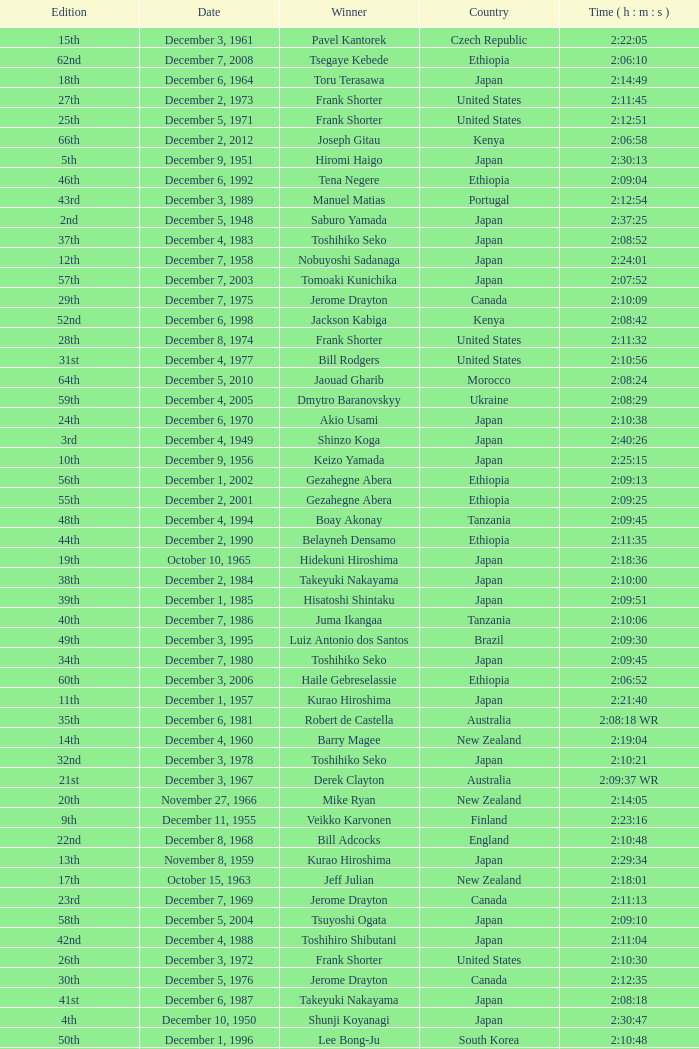On what date did Lee Bong-Ju win in 2:10:48? December 1, 1996. Can you parse all the data within this table? {'header': ['Edition', 'Date', 'Winner', 'Country', 'Time ( h : m : s )'], 'rows': [['15th', 'December 3, 1961', 'Pavel Kantorek', 'Czech Republic', '2:22:05'], ['62nd', 'December 7, 2008', 'Tsegaye Kebede', 'Ethiopia', '2:06:10'], ['18th', 'December 6, 1964', 'Toru Terasawa', 'Japan', '2:14:49'], ['27th', 'December 2, 1973', 'Frank Shorter', 'United States', '2:11:45'], ['25th', 'December 5, 1971', 'Frank Shorter', 'United States', '2:12:51'], ['66th', 'December 2, 2012', 'Joseph Gitau', 'Kenya', '2:06:58'], ['5th', 'December 9, 1951', 'Hiromi Haigo', 'Japan', '2:30:13'], ['46th', 'December 6, 1992', 'Tena Negere', 'Ethiopia', '2:09:04'], ['43rd', 'December 3, 1989', 'Manuel Matias', 'Portugal', '2:12:54'], ['2nd', 'December 5, 1948', 'Saburo Yamada', 'Japan', '2:37:25'], ['37th', 'December 4, 1983', 'Toshihiko Seko', 'Japan', '2:08:52'], ['12th', 'December 7, 1958', 'Nobuyoshi Sadanaga', 'Japan', '2:24:01'], ['57th', 'December 7, 2003', 'Tomoaki Kunichika', 'Japan', '2:07:52'], ['29th', 'December 7, 1975', 'Jerome Drayton', 'Canada', '2:10:09'], ['52nd', 'December 6, 1998', 'Jackson Kabiga', 'Kenya', '2:08:42'], ['28th', 'December 8, 1974', 'Frank Shorter', 'United States', '2:11:32'], ['31st', 'December 4, 1977', 'Bill Rodgers', 'United States', '2:10:56'], ['64th', 'December 5, 2010', 'Jaouad Gharib', 'Morocco', '2:08:24'], ['59th', 'December 4, 2005', 'Dmytro Baranovskyy', 'Ukraine', '2:08:29'], ['24th', 'December 6, 1970', 'Akio Usami', 'Japan', '2:10:38'], ['3rd', 'December 4, 1949', 'Shinzo Koga', 'Japan', '2:40:26'], ['10th', 'December 9, 1956', 'Keizo Yamada', 'Japan', '2:25:15'], ['56th', 'December 1, 2002', 'Gezahegne Abera', 'Ethiopia', '2:09:13'], ['55th', 'December 2, 2001', 'Gezahegne Abera', 'Ethiopia', '2:09:25'], ['48th', 'December 4, 1994', 'Boay Akonay', 'Tanzania', '2:09:45'], ['44th', 'December 2, 1990', 'Belayneh Densamo', 'Ethiopia', '2:11:35'], ['19th', 'October 10, 1965', 'Hidekuni Hiroshima', 'Japan', '2:18:36'], ['38th', 'December 2, 1984', 'Takeyuki Nakayama', 'Japan', '2:10:00'], ['39th', 'December 1, 1985', 'Hisatoshi Shintaku', 'Japan', '2:09:51'], ['40th', 'December 7, 1986', 'Juma Ikangaa', 'Tanzania', '2:10:06'], ['49th', 'December 3, 1995', 'Luiz Antonio dos Santos', 'Brazil', '2:09:30'], ['34th', 'December 7, 1980', 'Toshihiko Seko', 'Japan', '2:09:45'], ['60th', 'December 3, 2006', 'Haile Gebreselassie', 'Ethiopia', '2:06:52'], ['11th', 'December 1, 1957', 'Kurao Hiroshima', 'Japan', '2:21:40'], ['35th', 'December 6, 1981', 'Robert de Castella', 'Australia', '2:08:18 WR'], ['14th', 'December 4, 1960', 'Barry Magee', 'New Zealand', '2:19:04'], ['32nd', 'December 3, 1978', 'Toshihiko Seko', 'Japan', '2:10:21'], ['21st', 'December 3, 1967', 'Derek Clayton', 'Australia', '2:09:37 WR'], ['20th', 'November 27, 1966', 'Mike Ryan', 'New Zealand', '2:14:05'], ['9th', 'December 11, 1955', 'Veikko Karvonen', 'Finland', '2:23:16'], ['22nd', 'December 8, 1968', 'Bill Adcocks', 'England', '2:10:48'], ['13th', 'November 8, 1959', 'Kurao Hiroshima', 'Japan', '2:29:34'], ['17th', 'October 15, 1963', 'Jeff Julian', 'New Zealand', '2:18:01'], ['23rd', 'December 7, 1969', 'Jerome Drayton', 'Canada', '2:11:13'], ['58th', 'December 5, 2004', 'Tsuyoshi Ogata', 'Japan', '2:09:10'], ['42nd', 'December 4, 1988', 'Toshihiro Shibutani', 'Japan', '2:11:04'], ['26th', 'December 3, 1972', 'Frank Shorter', 'United States', '2:10:30'], ['30th', 'December 5, 1976', 'Jerome Drayton', 'Canada', '2:12:35'], ['41st', 'December 6, 1987', 'Takeyuki Nakayama', 'Japan', '2:08:18'], ['4th', 'December 10, 1950', 'Shunji Koyanagi', 'Japan', '2:30:47'], ['50th', 'December 1, 1996', 'Lee Bong-Ju', 'South Korea', '2:10:48'], ['7th', 'December 6, 1953', 'Hideo Hamamura', 'Japan', '2:27:26'], ['51st', 'December 7, 1997', 'Josia Thugwane', 'South Africa', '2:07:28'], ['33rd', 'December 2, 1979', 'Toshihiko Seko', 'Japan', '2:10:35'], ['16th', 'December 2, 1962', 'Toru Terasawa', 'Japan', '2:16:19'], ['36th', 'December 5, 1982', 'Paul Ballinger', 'New Zealand', '2:10:15'], ['6th', 'December 7, 1952', 'Katsuo Nishida', 'Japan', '2:27:59'], ['54th', 'December 3, 2000', 'Atsushi Fujita', 'Japan', '2:06:51 NR'], ['8th', 'December 5, 1954', 'Reinaldo Gorno', 'Argentina', '2:24:55'], ['63rd', 'December 6, 2009', 'Tsegaye Kebede', 'Ethiopia', '2:05:18'], ['45th', 'December 1, 1991', 'Shuichi Morita', 'Japan', '2:10:58'], ['1st', 'December 7, 1947', 'Toshikazu Wada', 'Japan', '2:45:45'], ['61st', 'December 2, 2007', 'Samuel Wanjiru', 'Kenya', '2:06:39'], ['65th', 'December 4, 2011', 'Josphat Ndambiri', 'Kenya', '2:07:36'], ['53rd', 'December 5, 1999', 'Gezahegne Abera', 'Ethiopia', '2:07:54'], ['47th', 'December 5, 1993', 'Dionicio Cerón', 'Mexico', '2:08:51']]} 